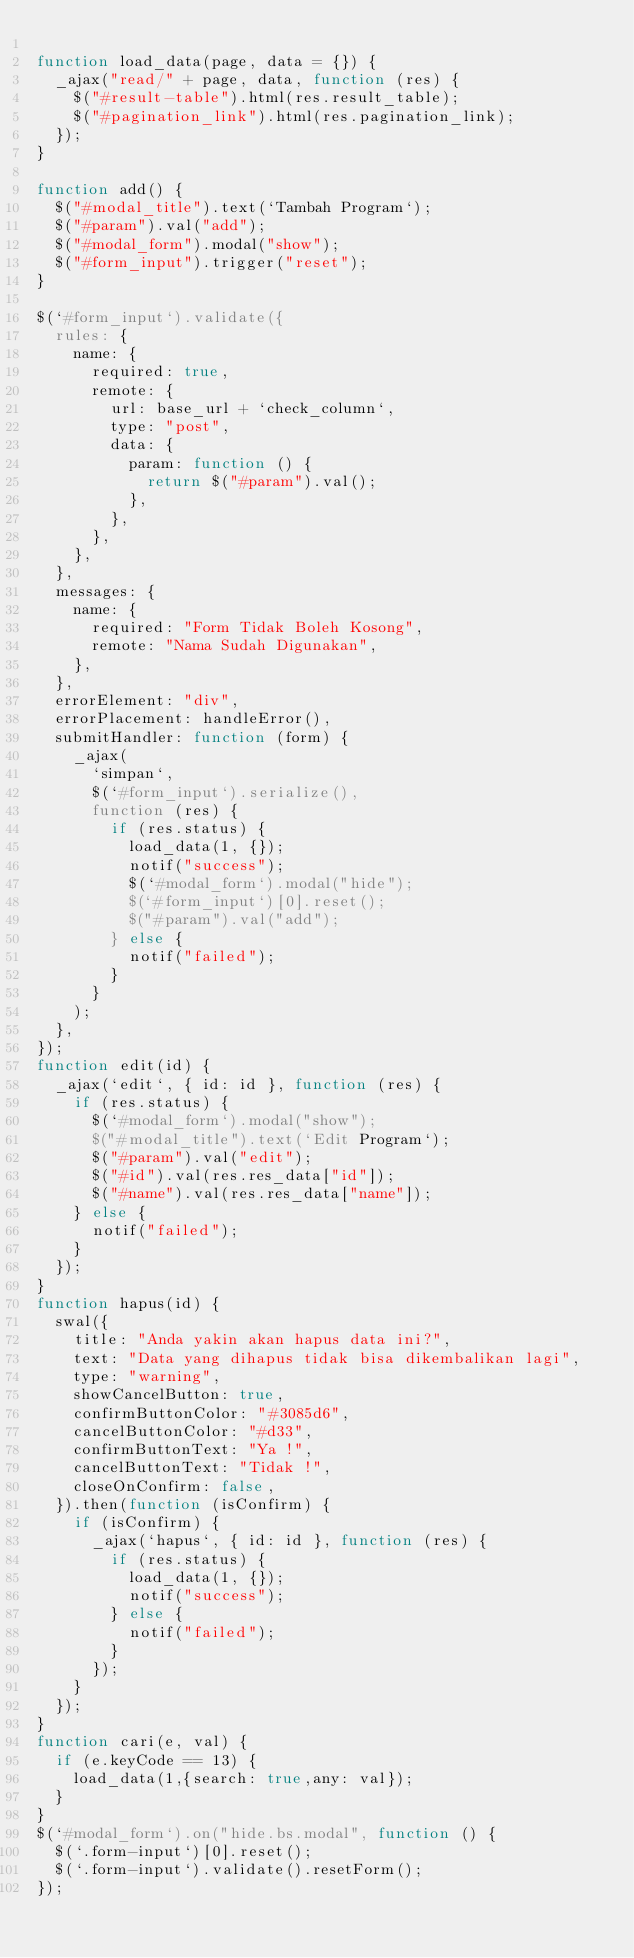Convert code to text. <code><loc_0><loc_0><loc_500><loc_500><_JavaScript_>
function load_data(page, data = {}) {
	_ajax("read/" + page, data, function (res) {
		$("#result-table").html(res.result_table);
		$("#pagination_link").html(res.pagination_link);
	});
}

function add() {
	$("#modal_title").text(`Tambah Program`);
	$("#param").val("add");
	$("#modal_form").modal("show");
	$("#form_input").trigger("reset");
}

$(`#form_input`).validate({
	rules: {
		name: {
			required: true,
			remote: {
				url: base_url + `check_column`,
				type: "post",
				data: {
					param: function () {
						return $("#param").val();
					},
				},
			},
		},
	},
	messages: {
		name: {
			required: "Form Tidak Boleh Kosong",
			remote: "Nama Sudah Digunakan",
		},
	},
	errorElement: "div",
	errorPlacement: handleError(),
	submitHandler: function (form) {
		_ajax(
			`simpan`,
			$(`#form_input`).serialize(),
			function (res) {
				if (res.status) {
					load_data(1, {});
					notif("success");
					$(`#modal_form`).modal("hide");
					$(`#form_input`)[0].reset();
					$("#param").val("add");
				} else {
					notif("failed");
				}
			}
		);
	},
});
function edit(id) {
	_ajax(`edit`, { id: id }, function (res) {
		if (res.status) {
			$(`#modal_form`).modal("show");
			$("#modal_title").text(`Edit Program`);
			$("#param").val("edit");
			$("#id").val(res.res_data["id"]);
			$("#name").val(res.res_data["name"]);
		} else {
			notif("failed");
		}
	});
}
function hapus(id) {
	swal({
		title: "Anda yakin akan hapus data ini?",
		text: "Data yang dihapus tidak bisa dikembalikan lagi",
		type: "warning",
		showCancelButton: true,
		confirmButtonColor: "#3085d6",
		cancelButtonColor: "#d33",
		confirmButtonText: "Ya !",
		cancelButtonText: "Tidak !",
		closeOnConfirm: false,
	}).then(function (isConfirm) {
		if (isConfirm) {
			_ajax(`hapus`, { id: id }, function (res) {
				if (res.status) {
					load_data(1, {});
					notif("success");
				} else {
					notif("failed");
				}
			});
		}
	});
}
function cari(e, val) {
	if (e.keyCode == 13) {
		load_data(1,{search: true,any: val});
	}
}
$(`#modal_form`).on("hide.bs.modal", function () {
	$(`.form-input`)[0].reset();
	$(`.form-input`).validate().resetForm();
});</code> 